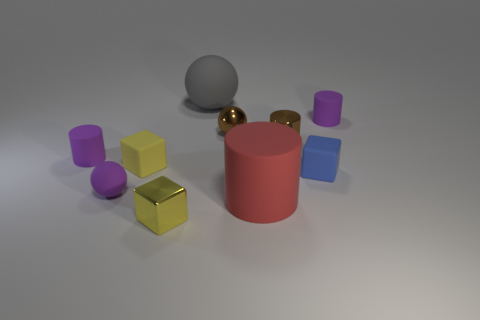What number of red things are either matte cylinders or large rubber cylinders?
Offer a terse response. 1. There is a tiny matte object that is on the right side of the large cylinder and behind the small blue thing; what color is it?
Keep it short and to the point. Purple. Is the material of the sphere that is on the right side of the large sphere the same as the cylinder that is behind the small brown metallic cylinder?
Offer a terse response. No. Is the number of small rubber cubes in front of the big red thing greater than the number of matte things that are to the right of the tiny yellow shiny cube?
Provide a short and direct response. No. There is a red object that is the same size as the gray ball; what is its shape?
Offer a very short reply. Cylinder. What number of things are either large things or purple cylinders that are on the left side of the brown metallic cylinder?
Keep it short and to the point. 3. Is the shiny cylinder the same color as the large cylinder?
Provide a succinct answer. No. There is a brown metallic cylinder; how many small metal blocks are left of it?
Your answer should be compact. 1. The tiny ball that is the same material as the gray object is what color?
Your answer should be compact. Purple. What number of metallic things are large red things or large green balls?
Provide a succinct answer. 0. 